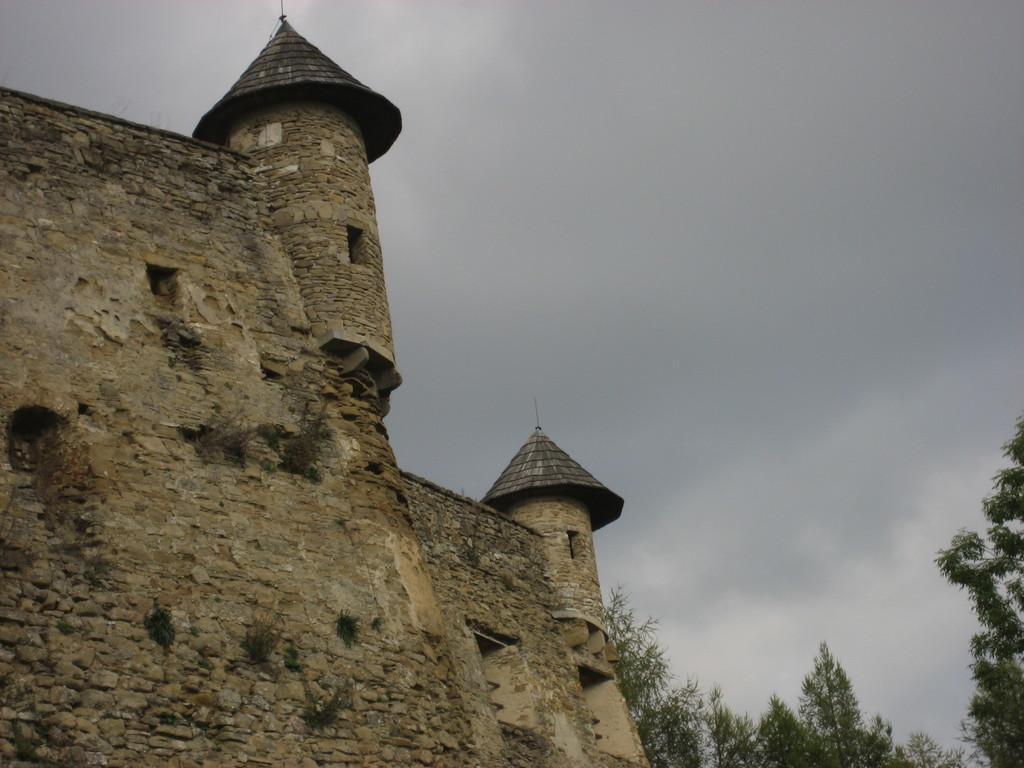What type of structure is present in the image? There is a building in the image. What type of vegetation is visible in the image? There are trees in the image. What part of the natural environment is visible in the image? The sky is visible in the background of the image. Can you hear the people driving by in the image? There is no reference to people driving by in the image, so it is not possible to answer that question. 